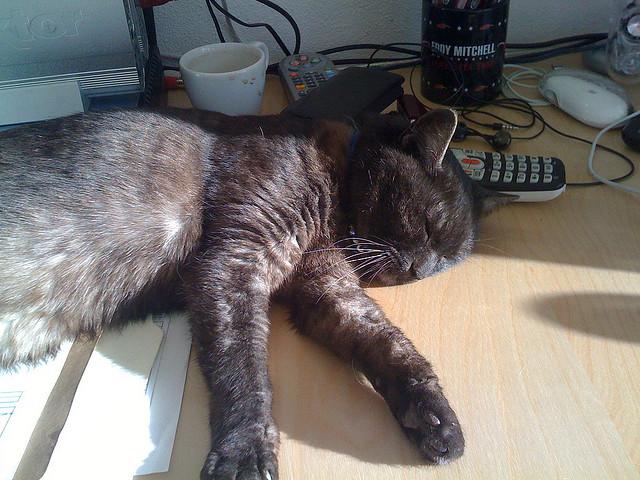Is the cat warm?
Answer briefly. Yes. What words are on the black mug?
Give a very brief answer. Mitchell. How many remotes are on the desk?
Keep it brief. 2. 